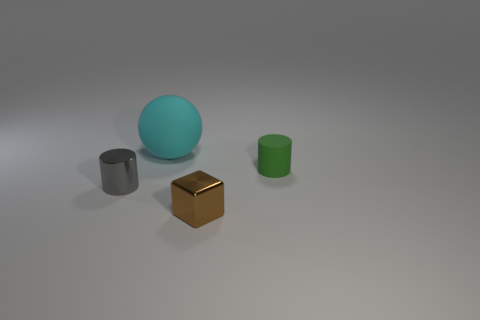Add 4 tiny brown cubes. How many objects exist? 8 Subtract all blocks. How many objects are left? 3 Subtract all big brown metal objects. Subtract all large matte objects. How many objects are left? 3 Add 3 brown metal blocks. How many brown metal blocks are left? 4 Add 1 green matte objects. How many green matte objects exist? 2 Subtract 0 purple cylinders. How many objects are left? 4 